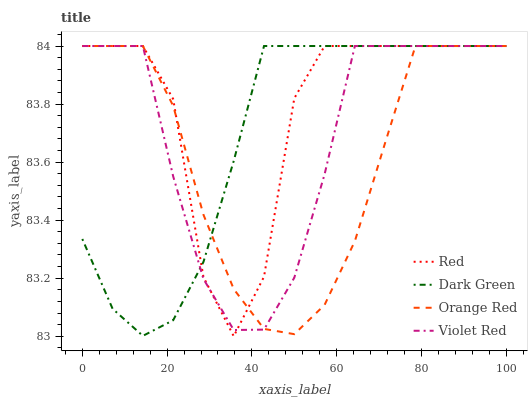Does Orange Red have the minimum area under the curve?
Answer yes or no. Yes. Does Red have the maximum area under the curve?
Answer yes or no. Yes. Does Red have the minimum area under the curve?
Answer yes or no. No. Does Orange Red have the maximum area under the curve?
Answer yes or no. No. Is Dark Green the smoothest?
Answer yes or no. Yes. Is Red the roughest?
Answer yes or no. Yes. Is Orange Red the smoothest?
Answer yes or no. No. Is Orange Red the roughest?
Answer yes or no. No. Does Orange Red have the lowest value?
Answer yes or no. No. Does Dark Green have the highest value?
Answer yes or no. Yes. Does Violet Red intersect Red?
Answer yes or no. Yes. Is Violet Red less than Red?
Answer yes or no. No. Is Violet Red greater than Red?
Answer yes or no. No. 